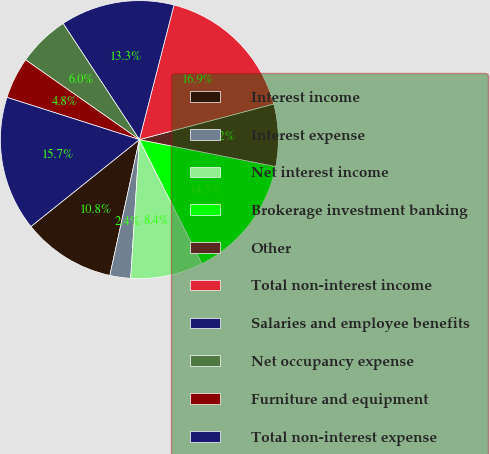<chart> <loc_0><loc_0><loc_500><loc_500><pie_chart><fcel>Interest income<fcel>Interest expense<fcel>Net interest income<fcel>Brokerage investment banking<fcel>Other<fcel>Total non-interest income<fcel>Salaries and employee benefits<fcel>Net occupancy expense<fcel>Furniture and equipment<fcel>Total non-interest expense<nl><fcel>10.84%<fcel>2.41%<fcel>8.43%<fcel>14.46%<fcel>7.23%<fcel>16.87%<fcel>13.25%<fcel>6.02%<fcel>4.82%<fcel>15.66%<nl></chart> 